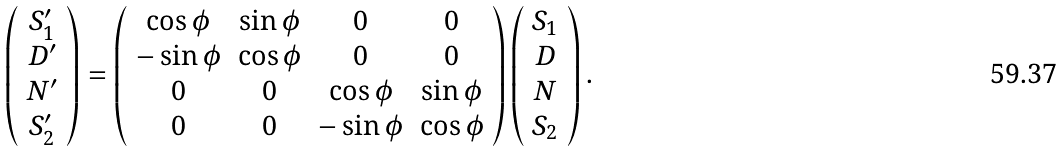Convert formula to latex. <formula><loc_0><loc_0><loc_500><loc_500>\left ( \begin{array} { c } S _ { 1 } ^ { \prime } \\ D ^ { \prime } \\ N ^ { \prime } \\ S _ { 2 } ^ { \prime } \end{array} \right ) = \left ( \begin{array} { c c c c } \cos \phi & \sin \phi & 0 & 0 \\ - \sin \phi & \cos \phi & 0 & 0 \\ 0 & 0 & \cos \phi & \sin \phi \\ 0 & 0 & - \sin \phi & \cos \phi \end{array} \right ) \left ( \begin{array} { c } S _ { 1 } \\ D \\ N \\ S _ { 2 } \end{array} \right ) .</formula> 